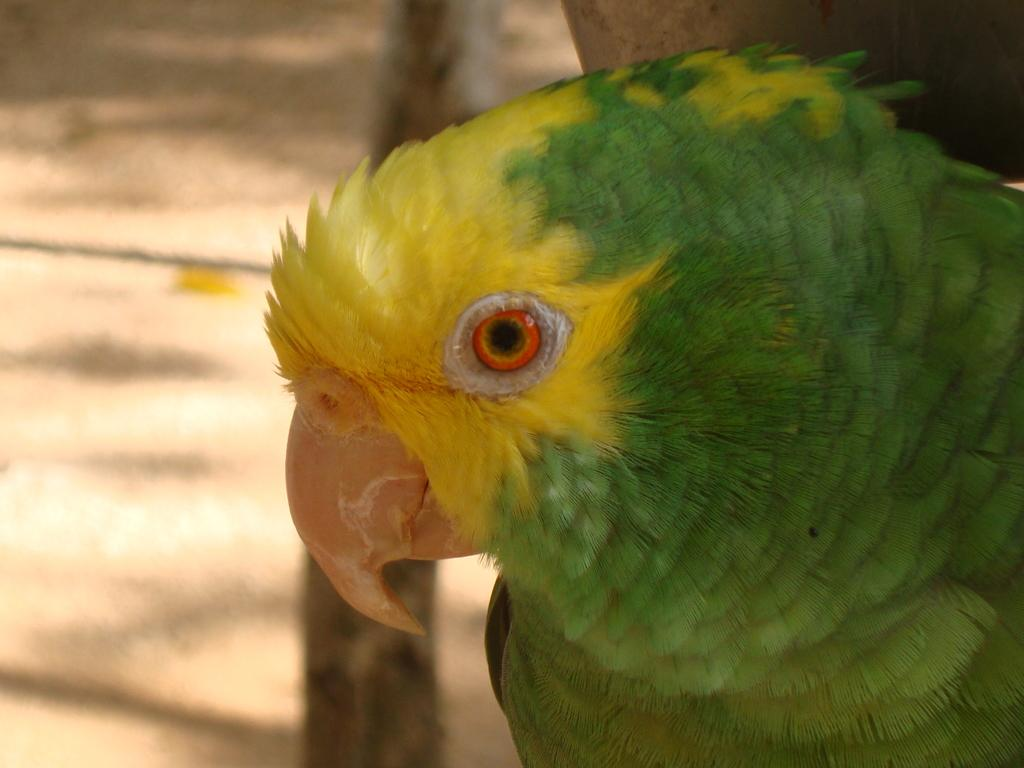What type of bird is in the image? There is a budgerigar in the image. Where is the budgerigar located in the image? The budgerigar is on the right side of the image. What can be seen in the background of the image? There is ground and a log visible in the background of the image. What caption is written under the budgerigar in the image? There is no caption visible under the budgerigar in the image. 